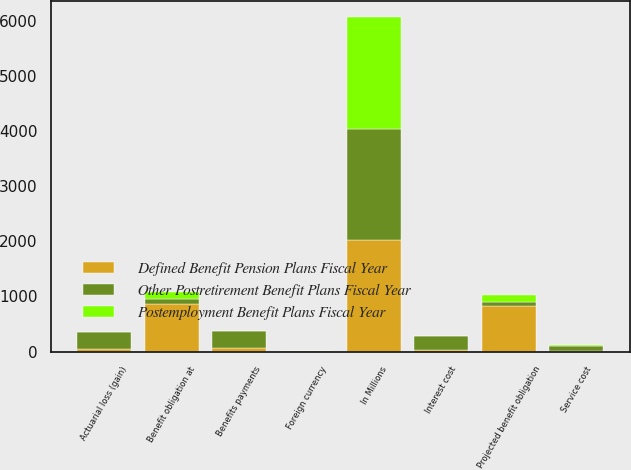Convert chart to OTSL. <chart><loc_0><loc_0><loc_500><loc_500><stacked_bar_chart><ecel><fcel>In Millions<fcel>Benefit obligation at<fcel>Service cost<fcel>Interest cost<fcel>Actuarial loss (gain)<fcel>Benefits payments<fcel>Foreign currency<fcel>Projected benefit obligation<nl><fcel>Other Postretirement Benefit Plans Fiscal Year<fcel>2019<fcel>78.4<fcel>94.6<fcel>248<fcel>301.8<fcel>305.8<fcel>7.1<fcel>78.4<nl><fcel>Defined Benefit Pension Plans Fiscal Year<fcel>2019<fcel>871.8<fcel>9.9<fcel>33.1<fcel>45.4<fcel>62.2<fcel>0.6<fcel>824.1<nl><fcel>Postemployment Benefit Plans Fiscal Year<fcel>2019<fcel>126.7<fcel>7.6<fcel>3<fcel>2.6<fcel>13.2<fcel>0.4<fcel>128<nl></chart> 